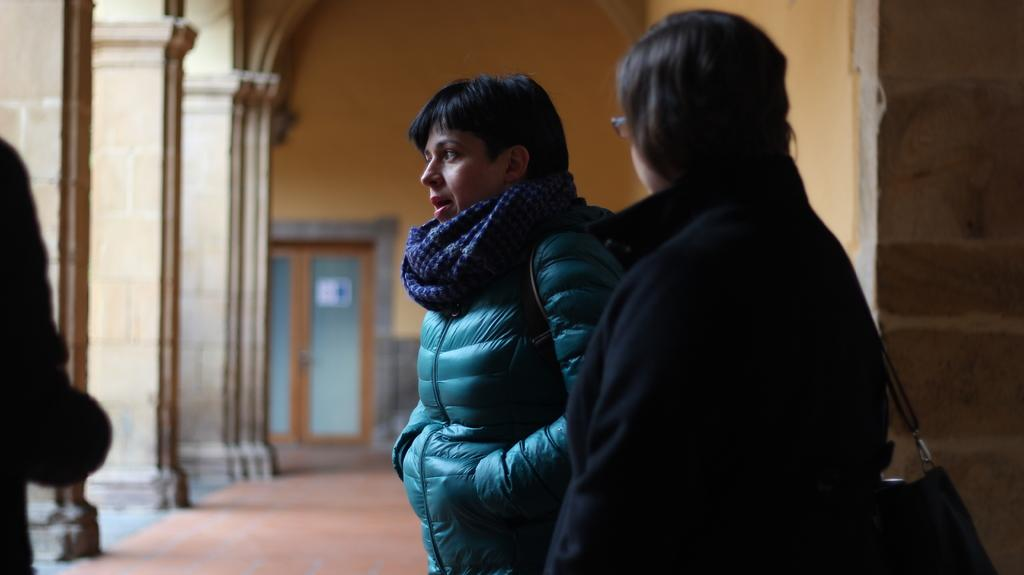How many people are present in the image? There are three persons in the image. What can be seen in the background of the image? There is a wall in the background of the image. Is there any entrance or exit visible in the wall? Yes, there is a door in the wall. What architectural features are present on the left side of the image? There are three pillars on the left side of the image. What type of pollution can be seen coming from the design in the image? There is no design or pollution present in the image. How is the steam being used by the persons in the image? There is no steam present in the image. 